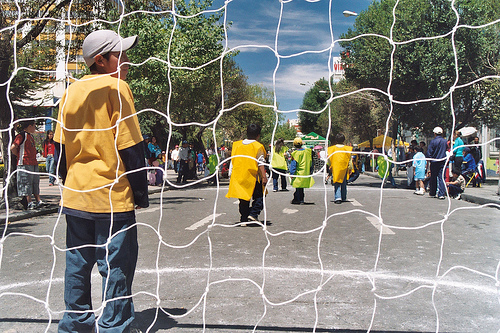<image>
Is there a net behind the boy? Yes. From this viewpoint, the net is positioned behind the boy, with the boy partially or fully occluding the net. 